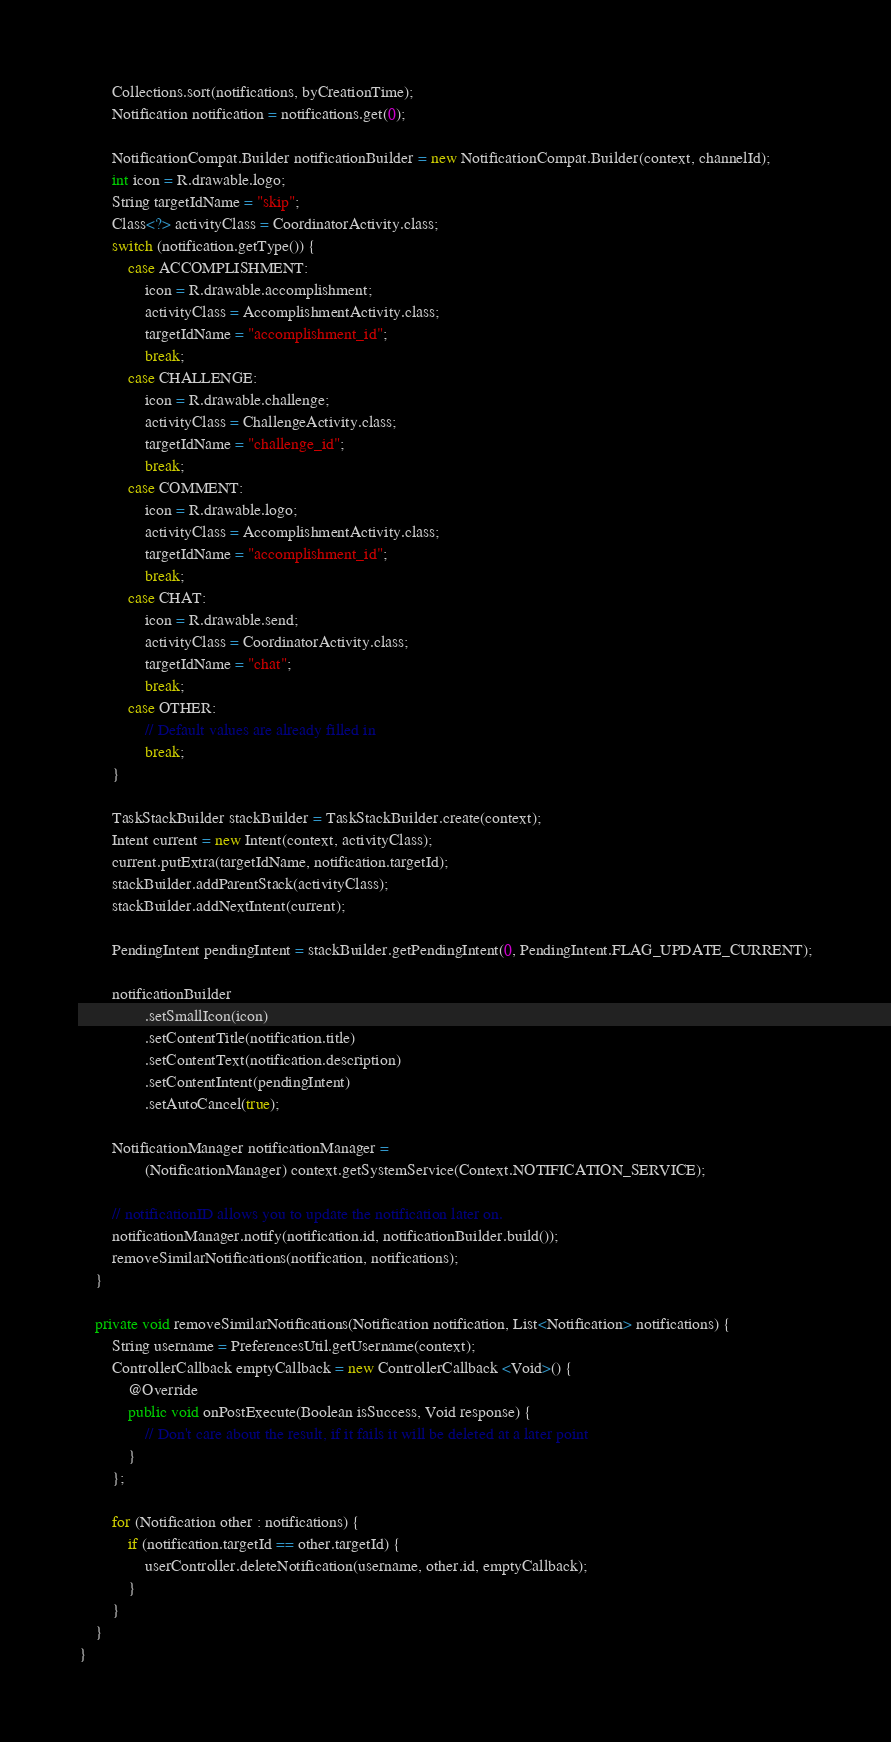Convert code to text. <code><loc_0><loc_0><loc_500><loc_500><_Java_>
        Collections.sort(notifications, byCreationTime);
        Notification notification = notifications.get(0);

        NotificationCompat.Builder notificationBuilder = new NotificationCompat.Builder(context, channelId);
        int icon = R.drawable.logo;
        String targetIdName = "skip";
        Class<?> activityClass = CoordinatorActivity.class;
        switch (notification.getType()) {
            case ACCOMPLISHMENT:
                icon = R.drawable.accomplishment;
                activityClass = AccomplishmentActivity.class;
                targetIdName = "accomplishment_id";
                break;
            case CHALLENGE:
                icon = R.drawable.challenge;
                activityClass = ChallengeActivity.class;
                targetIdName = "challenge_id";
                break;
            case COMMENT:
                icon = R.drawable.logo;
                activityClass = AccomplishmentActivity.class;
                targetIdName = "accomplishment_id";
                break;
            case CHAT:
                icon = R.drawable.send;
                activityClass = CoordinatorActivity.class;
                targetIdName = "chat";
                break;
            case OTHER:
                // Default values are already filled in
                break;
        }

        TaskStackBuilder stackBuilder = TaskStackBuilder.create(context);
        Intent current = new Intent(context, activityClass);
        current.putExtra(targetIdName, notification.targetId);
        stackBuilder.addParentStack(activityClass);
        stackBuilder.addNextIntent(current);

        PendingIntent pendingIntent = stackBuilder.getPendingIntent(0, PendingIntent.FLAG_UPDATE_CURRENT);

        notificationBuilder
                .setSmallIcon(icon)
                .setContentTitle(notification.title)
                .setContentText(notification.description)
                .setContentIntent(pendingIntent)
                .setAutoCancel(true);

        NotificationManager notificationManager =
                (NotificationManager) context.getSystemService(Context.NOTIFICATION_SERVICE);

        // notificationID allows you to update the notification later on.
        notificationManager.notify(notification.id, notificationBuilder.build());
        removeSimilarNotifications(notification, notifications);
    }

    private void removeSimilarNotifications(Notification notification, List<Notification> notifications) {
        String username = PreferencesUtil.getUsername(context);
        ControllerCallback emptyCallback = new ControllerCallback <Void>() {
            @Override
            public void onPostExecute(Boolean isSuccess, Void response) {
                // Don't care about the result, if it fails it will be deleted at a later point
            }
        };

        for (Notification other : notifications) {
            if (notification.targetId == other.targetId) {
                userController.deleteNotification(username, other.id, emptyCallback);
            }
        }
    }
}</code> 